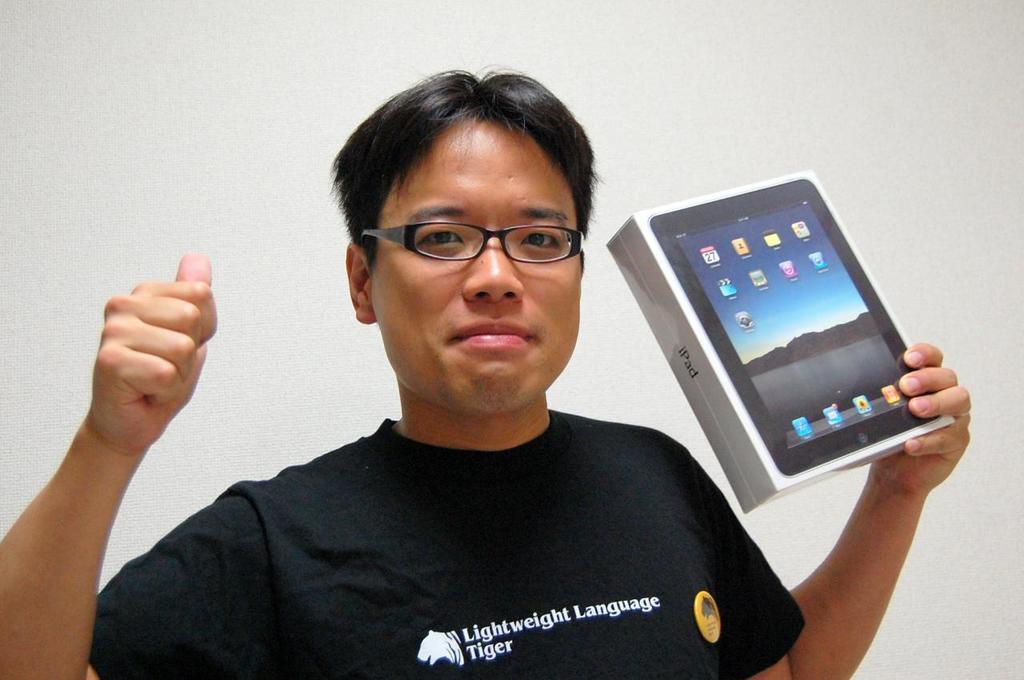What is the main subject of the image? The main subject of the image is a man. Can you describe the man's clothing? The man is wearing a black T-shirt. What accessory is the man wearing? The man is wearing spectacles. What is the man holding in the image? The man is holding a box in one hand. What can be seen in the background of the image? There is a wall in the background of the image. What type of soda is the man drinking in the image? There is no soda present in the image; the man is holding a box. What hobbies does the man have, as depicted in the image? The image does not provide information about the man's hobbies. 